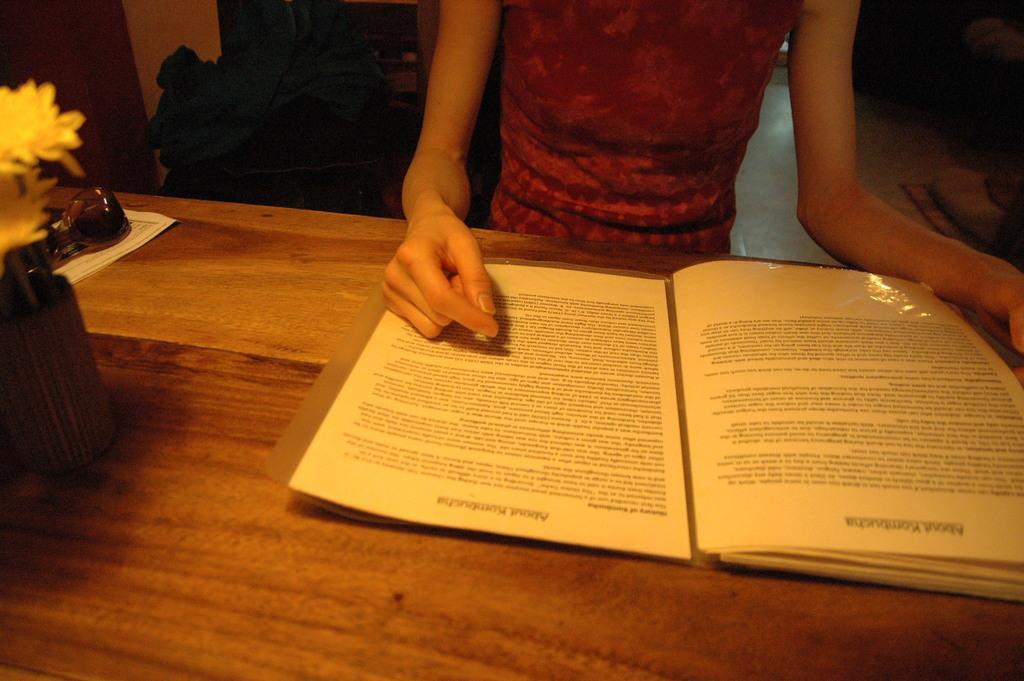How would you summarize this image in a sentence or two? In this picture a person is reading a book present on the table. 